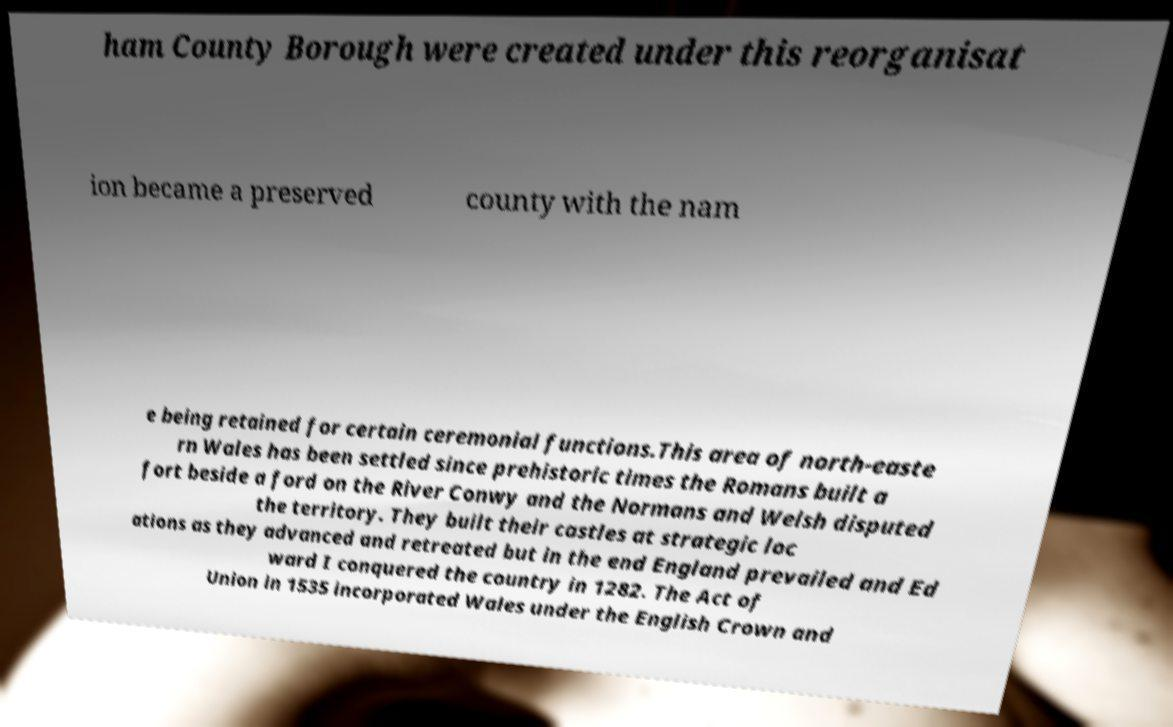For documentation purposes, I need the text within this image transcribed. Could you provide that? ham County Borough were created under this reorganisat ion became a preserved county with the nam e being retained for certain ceremonial functions.This area of north-easte rn Wales has been settled since prehistoric times the Romans built a fort beside a ford on the River Conwy and the Normans and Welsh disputed the territory. They built their castles at strategic loc ations as they advanced and retreated but in the end England prevailed and Ed ward I conquered the country in 1282. The Act of Union in 1535 incorporated Wales under the English Crown and 